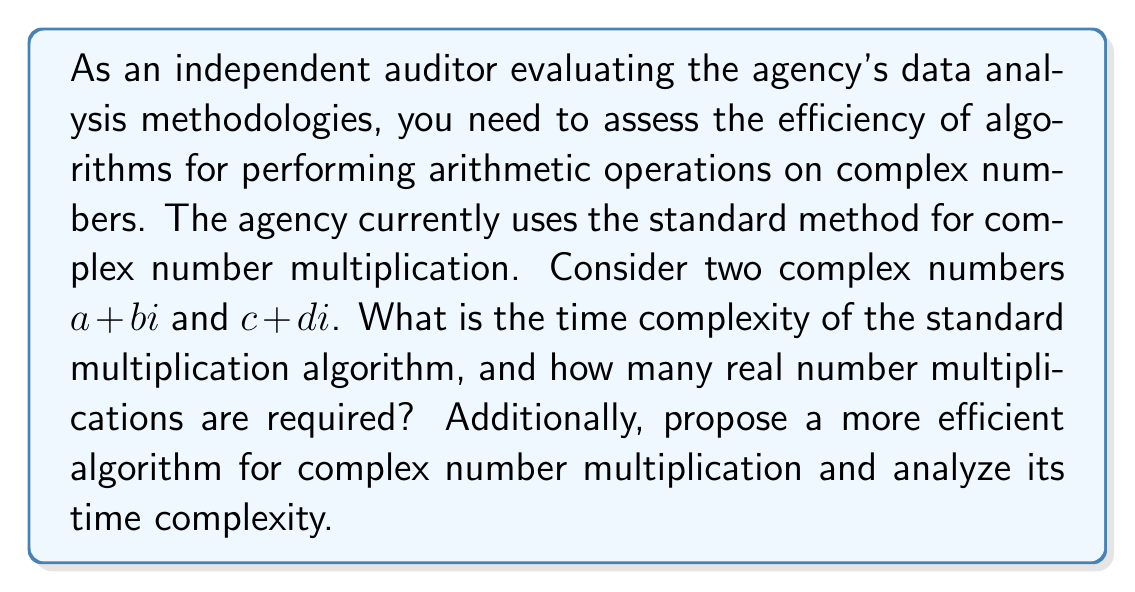Teach me how to tackle this problem. To evaluate the efficiency of algorithms for complex number arithmetic, we need to analyze their time complexity and the number of basic operations required.

1. Standard Complex Number Multiplication:
   The standard method for multiplying two complex numbers $(a + bi)(c + di)$ is:
   $$(a + bi)(c + di) = (ac - bd) + (ad + bc)i$$

   This method requires:
   - 4 real number multiplications: $ac$, $bd$, $ad$, $bc$
   - 1 subtraction and 1 addition

   Time Complexity: $O(1)$ (constant time) for a single multiplication, but the number of basic operations is important for large-scale computations.

2. Karatsuba Algorithm for Complex Multiplication:
   A more efficient algorithm is the Karatsuba method, which reduces the number of real multiplications:

   Let $P_1 = a \cdot c$
   Let $P_2 = b \cdot d$
   Let $P_3 = (a + b)(c + d)$

   Then, $(a + bi)(c + di) = (P_1 - P_2) + (P_3 - P_1 - P_2)i$

   This method requires:
   - 3 real number multiplications: $P_1$, $P_2$, $P_3$
   - 4 additions/subtractions

   Time Complexity: $O(1)$ (constant time) for a single multiplication, but with fewer basic multiplication operations.

For large-scale computations or when dealing with very large complex numbers, the Karatsuba algorithm can provide significant performance improvements. The reduction from 4 to 3 multiplications may seem small, but for matrix operations or when dealing with large numbers, this 25% reduction in multiplication operations can lead to substantial time savings.

When evaluating the agency's data analysis methodologies, it's important to consider:
1. The scale of complex number operations being performed
2. The precision requirements of the calculations
3. The hardware architecture on which the algorithms are implemented

For most standard applications, the difference in performance might be negligible. However, for high-performance computing or big data applications involving complex number arithmetic, implementing more efficient algorithms like Karatsuba could provide meaningful improvements in computational efficiency.
Answer: The standard complex number multiplication algorithm has a time complexity of $O(1)$ and requires 4 real number multiplications. A more efficient algorithm, such as the Karatsuba method, also has a time complexity of $O(1)$ but requires only 3 real number multiplications, potentially offering a 25% reduction in multiplication operations for large-scale computations. 